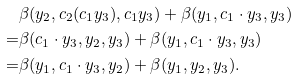Convert formula to latex. <formula><loc_0><loc_0><loc_500><loc_500>& \beta ( y _ { 2 } , c _ { 2 } ( c _ { 1 } y _ { 3 } ) , c _ { 1 } y _ { 3 } ) + \beta ( y _ { 1 } , c _ { 1 } \cdot y _ { 3 } , y _ { 3 } ) \\ = & \beta ( c _ { 1 } \cdot y _ { 3 } , y _ { 2 } , y _ { 3 } ) + \beta ( y _ { 1 } , c _ { 1 } \cdot y _ { 3 } , y _ { 3 } ) \\ = & \beta ( y _ { 1 } , c _ { 1 } \cdot y _ { 3 } , y _ { 2 } ) + \beta ( y _ { 1 } , y _ { 2 } , y _ { 3 } ) .</formula> 